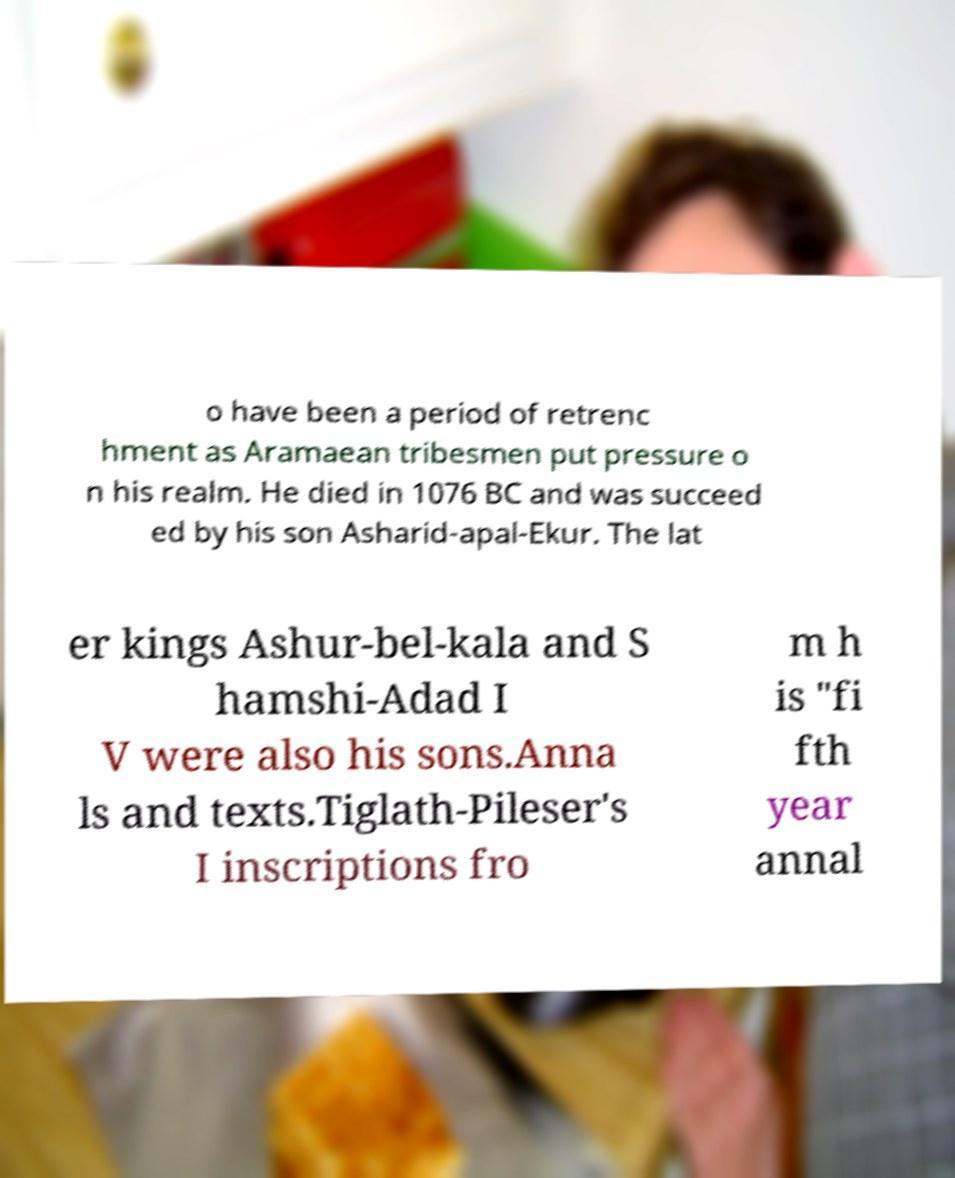Can you accurately transcribe the text from the provided image for me? o have been a period of retrenc hment as Aramaean tribesmen put pressure o n his realm. He died in 1076 BC and was succeed ed by his son Asharid-apal-Ekur. The lat er kings Ashur-bel-kala and S hamshi-Adad I V were also his sons.Anna ls and texts.Tiglath-Pileser's I inscriptions fro m h is "fi fth year annal 